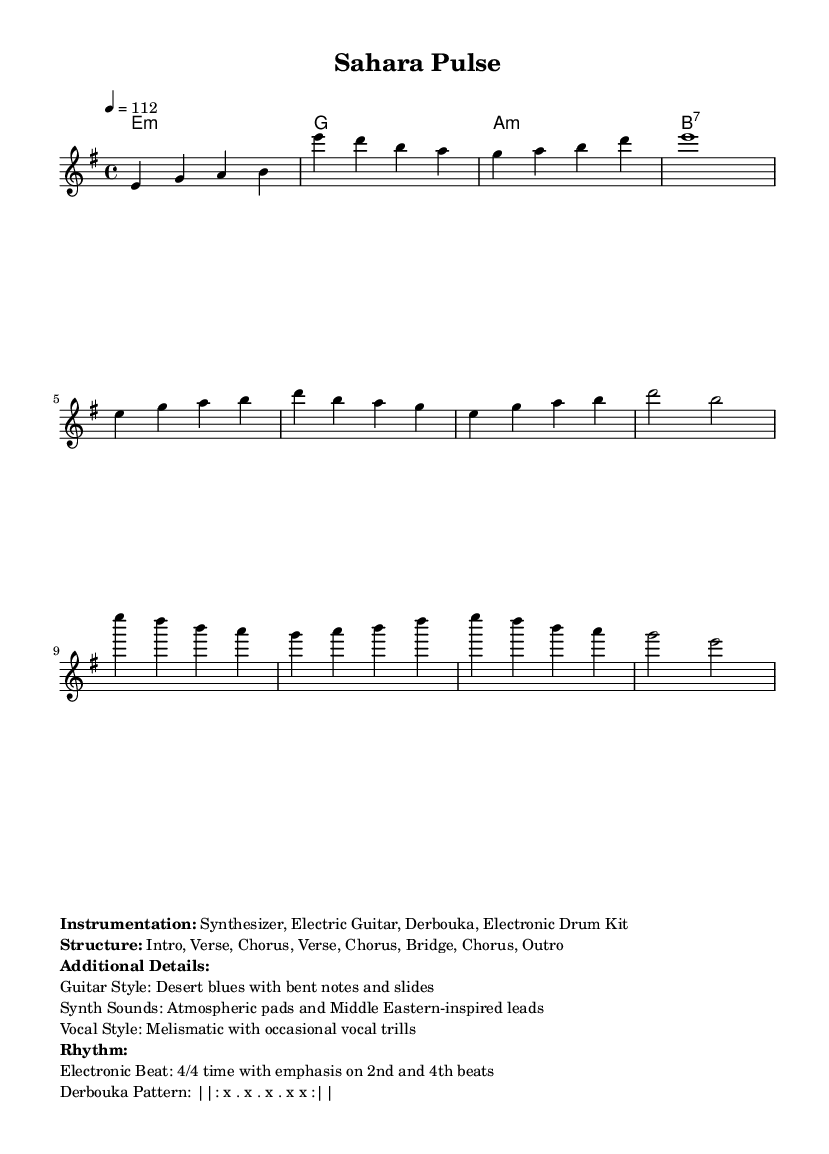What is the key signature of this music? The key signature is E minor, which typically indicates one sharpened note (F#). This can be identified from the global section of the code, where it states "\key e \minor".
Answer: E minor What is the time signature of this music? The time signature is 4/4, as indicated in the global section of the code with "\time 4/4". This means there are four beats in each measure and the quarter note gets one beat.
Answer: 4/4 What is the tempo marking in this music? The tempo marking is 112, which refers to the beats per minute (BPM) for the piece. This is specified in the global section with "\tempo 4 = 112".
Answer: 112 How many measures are in the verse section? The verse section consists of two measures, as can be seen in the melody part where the notes labeled under the verse encompass two distinct musical phrases measured in two bars.
Answer: 2 What instruments are used in this composition? The instruments listed are Synthesizer, Electric Guitar, Derbouka, and Electronic Drum Kit. This information is presented in the markup section, detailing the instrumentation used in the piece.
Answer: Synthesizer, Electric Guitar, Derbouka, Electronic Drum Kit What is the structural form of the music? The structure follows an Intro, Verse, Chorus, Verse, Chorus, Bridge, Chorus, and Outro format, which outlines the arrangement of the sections in the piece. This is also indicated in the markup details.
Answer: Intro, Verse, Chorus, Verse, Chorus, Bridge, Chorus, Outro 